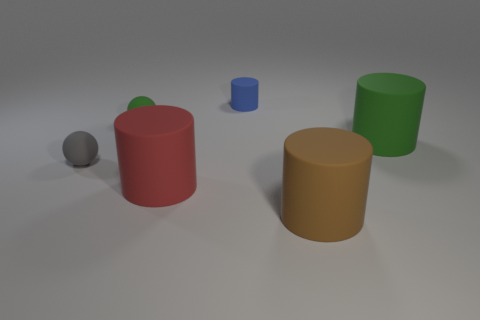Subtract all large brown cylinders. How many cylinders are left? 3 Subtract all red cylinders. How many cylinders are left? 3 Subtract all yellow cylinders. Subtract all red blocks. How many cylinders are left? 4 Add 3 matte balls. How many objects exist? 9 Subtract all cylinders. How many objects are left? 2 Add 1 large rubber objects. How many large rubber objects are left? 4 Add 2 tiny matte cubes. How many tiny matte cubes exist? 2 Subtract 0 green cubes. How many objects are left? 6 Subtract all big matte cylinders. Subtract all big cylinders. How many objects are left? 0 